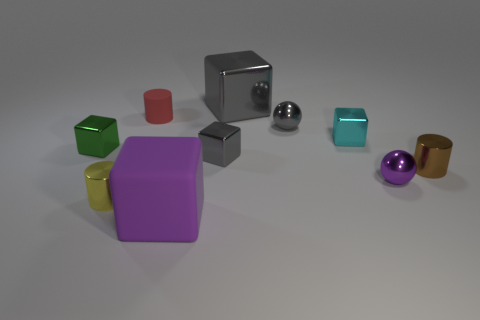How many gray cubes must be subtracted to get 1 gray cubes? 1 Subtract all tiny gray metal blocks. How many blocks are left? 4 Subtract all cylinders. How many objects are left? 7 Subtract 3 cylinders. How many cylinders are left? 0 Subtract all cyan cylinders. Subtract all cyan blocks. How many cylinders are left? 3 Subtract all red spheres. How many cyan cubes are left? 1 Subtract all tiny metallic spheres. Subtract all purple metallic things. How many objects are left? 7 Add 1 purple blocks. How many purple blocks are left? 2 Add 7 small purple metallic spheres. How many small purple metallic spheres exist? 8 Subtract all gray cubes. How many cubes are left? 3 